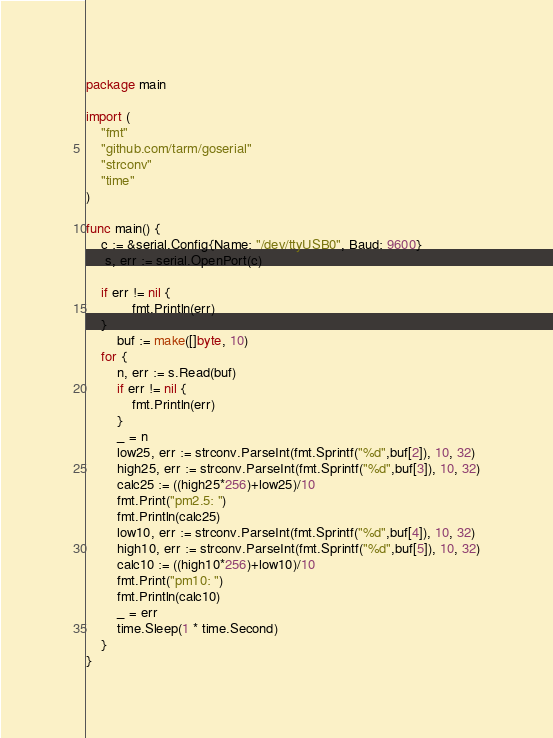<code> <loc_0><loc_0><loc_500><loc_500><_Go_>package main

import (
	"fmt"
	"github.com/tarm/goserial"
	"strconv"
	"time"
)

func main() {
	c := &serial.Config{Name: "/dev/ttyUSB0", Baud: 9600}
	 s, err := serial.OpenPort(c)

    if err != nil {
            fmt.Println(err)
    }
	    buf := make([]byte, 10)
	for {
	    n, err := s.Read(buf)
	    if err != nil {
		    fmt.Println(err)
	    }
	    _ = n
		low25, err := strconv.ParseInt(fmt.Sprintf("%d",buf[2]), 10, 32)
		high25, err := strconv.ParseInt(fmt.Sprintf("%d",buf[3]), 10, 32)
		calc25 := ((high25*256)+low25)/10
		fmt.Print("pm2.5: ")
		fmt.Println(calc25)
		low10, err := strconv.ParseInt(fmt.Sprintf("%d",buf[4]), 10, 32)
		high10, err := strconv.ParseInt(fmt.Sprintf("%d",buf[5]), 10, 32)
		calc10 := ((high10*256)+low10)/10
		fmt.Print("pm10: ")
		fmt.Println(calc10)
		_ = err
		time.Sleep(1 * time.Second)
	}
}
</code> 